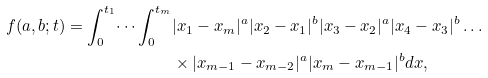Convert formula to latex. <formula><loc_0><loc_0><loc_500><loc_500>f ( a , b ; t ) = \int _ { 0 } ^ { t _ { 1 } } \dots \int _ { 0 } ^ { t _ { m } } & | x _ { 1 } - x _ { m } | ^ { a } | x _ { 2 } - x _ { 1 } | ^ { b } | x _ { 3 } - x _ { 2 } | ^ { a } | x _ { 4 } - x _ { 3 } | ^ { b } \dots \\ & \times | x _ { m - 1 } - x _ { m - 2 } | ^ { a } | x _ { m } - x _ { m - 1 } | ^ { b } d x ,</formula> 